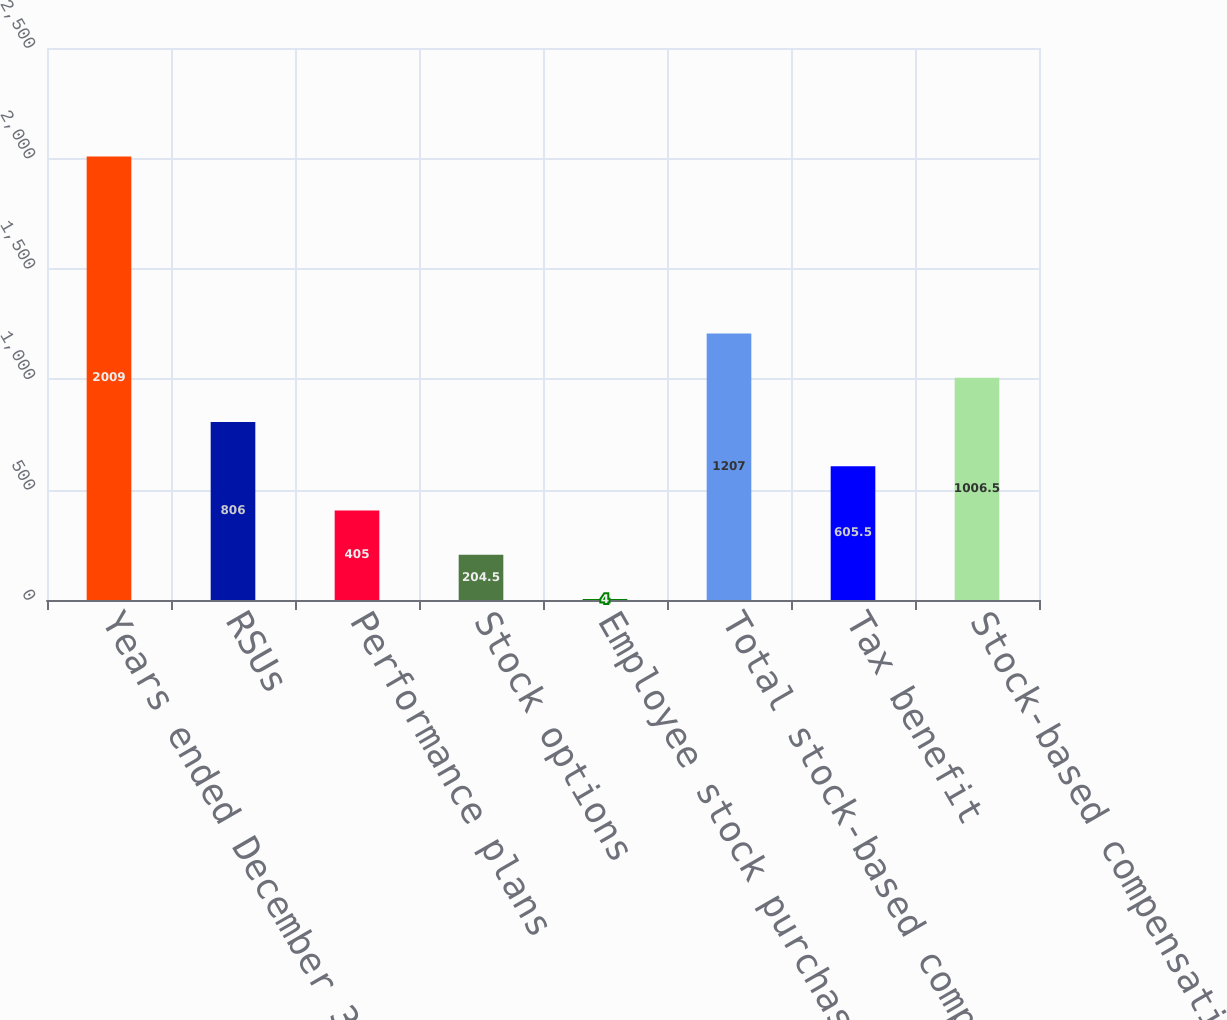Convert chart to OTSL. <chart><loc_0><loc_0><loc_500><loc_500><bar_chart><fcel>Years ended December 31<fcel>RSUs<fcel>Performance plans<fcel>Stock options<fcel>Employee stock purchase plans<fcel>Total stock-based compensation<fcel>Tax benefit<fcel>Stock-based compensation<nl><fcel>2009<fcel>806<fcel>405<fcel>204.5<fcel>4<fcel>1207<fcel>605.5<fcel>1006.5<nl></chart> 